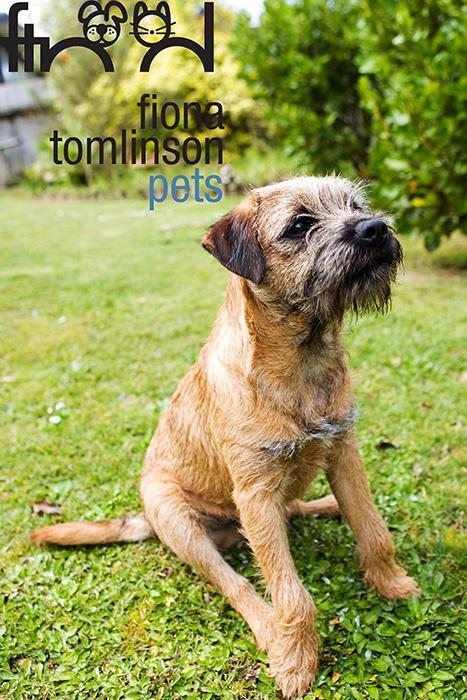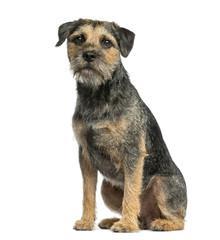The first image is the image on the left, the second image is the image on the right. Given the left and right images, does the statement "There is a dog outside in the grass in the center of both of the images." hold true? Answer yes or no. No. The first image is the image on the left, the second image is the image on the right. Considering the images on both sides, is "In both images, there's a border terrier sitting down." valid? Answer yes or no. Yes. 